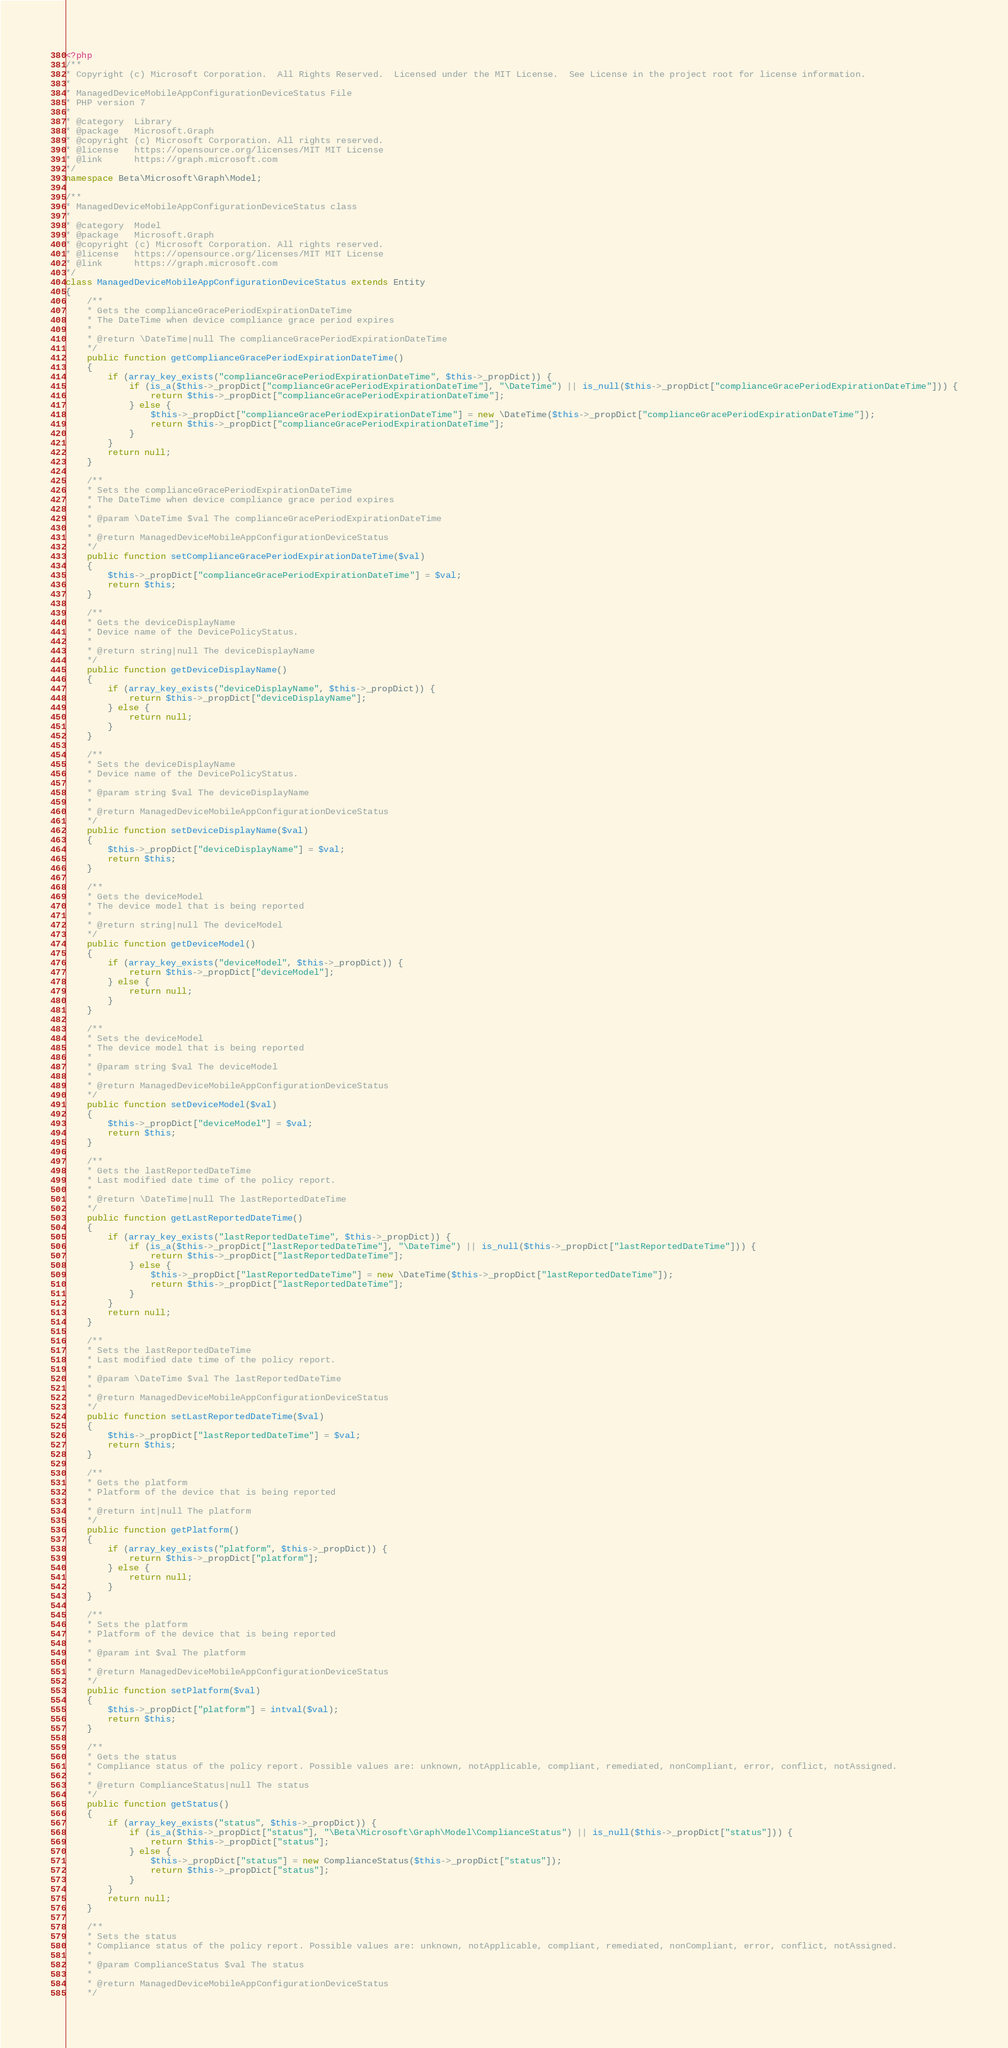<code> <loc_0><loc_0><loc_500><loc_500><_PHP_><?php
/**
* Copyright (c) Microsoft Corporation.  All Rights Reserved.  Licensed under the MIT License.  See License in the project root for license information.
* 
* ManagedDeviceMobileAppConfigurationDeviceStatus File
* PHP version 7
*
* @category  Library
* @package   Microsoft.Graph
* @copyright (c) Microsoft Corporation. All rights reserved.
* @license   https://opensource.org/licenses/MIT MIT License
* @link      https://graph.microsoft.com
*/
namespace Beta\Microsoft\Graph\Model;

/**
* ManagedDeviceMobileAppConfigurationDeviceStatus class
*
* @category  Model
* @package   Microsoft.Graph
* @copyright (c) Microsoft Corporation. All rights reserved.
* @license   https://opensource.org/licenses/MIT MIT License
* @link      https://graph.microsoft.com
*/
class ManagedDeviceMobileAppConfigurationDeviceStatus extends Entity
{
    /**
    * Gets the complianceGracePeriodExpirationDateTime
    * The DateTime when device compliance grace period expires
    *
    * @return \DateTime|null The complianceGracePeriodExpirationDateTime
    */
    public function getComplianceGracePeriodExpirationDateTime()
    {
        if (array_key_exists("complianceGracePeriodExpirationDateTime", $this->_propDict)) {
            if (is_a($this->_propDict["complianceGracePeriodExpirationDateTime"], "\DateTime") || is_null($this->_propDict["complianceGracePeriodExpirationDateTime"])) {
                return $this->_propDict["complianceGracePeriodExpirationDateTime"];
            } else {
                $this->_propDict["complianceGracePeriodExpirationDateTime"] = new \DateTime($this->_propDict["complianceGracePeriodExpirationDateTime"]);
                return $this->_propDict["complianceGracePeriodExpirationDateTime"];
            }
        }
        return null;
    }

    /**
    * Sets the complianceGracePeriodExpirationDateTime
    * The DateTime when device compliance grace period expires
    *
    * @param \DateTime $val The complianceGracePeriodExpirationDateTime
    *
    * @return ManagedDeviceMobileAppConfigurationDeviceStatus
    */
    public function setComplianceGracePeriodExpirationDateTime($val)
    {
        $this->_propDict["complianceGracePeriodExpirationDateTime"] = $val;
        return $this;
    }

    /**
    * Gets the deviceDisplayName
    * Device name of the DevicePolicyStatus.
    *
    * @return string|null The deviceDisplayName
    */
    public function getDeviceDisplayName()
    {
        if (array_key_exists("deviceDisplayName", $this->_propDict)) {
            return $this->_propDict["deviceDisplayName"];
        } else {
            return null;
        }
    }

    /**
    * Sets the deviceDisplayName
    * Device name of the DevicePolicyStatus.
    *
    * @param string $val The deviceDisplayName
    *
    * @return ManagedDeviceMobileAppConfigurationDeviceStatus
    */
    public function setDeviceDisplayName($val)
    {
        $this->_propDict["deviceDisplayName"] = $val;
        return $this;
    }

    /**
    * Gets the deviceModel
    * The device model that is being reported
    *
    * @return string|null The deviceModel
    */
    public function getDeviceModel()
    {
        if (array_key_exists("deviceModel", $this->_propDict)) {
            return $this->_propDict["deviceModel"];
        } else {
            return null;
        }
    }

    /**
    * Sets the deviceModel
    * The device model that is being reported
    *
    * @param string $val The deviceModel
    *
    * @return ManagedDeviceMobileAppConfigurationDeviceStatus
    */
    public function setDeviceModel($val)
    {
        $this->_propDict["deviceModel"] = $val;
        return $this;
    }

    /**
    * Gets the lastReportedDateTime
    * Last modified date time of the policy report.
    *
    * @return \DateTime|null The lastReportedDateTime
    */
    public function getLastReportedDateTime()
    {
        if (array_key_exists("lastReportedDateTime", $this->_propDict)) {
            if (is_a($this->_propDict["lastReportedDateTime"], "\DateTime") || is_null($this->_propDict["lastReportedDateTime"])) {
                return $this->_propDict["lastReportedDateTime"];
            } else {
                $this->_propDict["lastReportedDateTime"] = new \DateTime($this->_propDict["lastReportedDateTime"]);
                return $this->_propDict["lastReportedDateTime"];
            }
        }
        return null;
    }

    /**
    * Sets the lastReportedDateTime
    * Last modified date time of the policy report.
    *
    * @param \DateTime $val The lastReportedDateTime
    *
    * @return ManagedDeviceMobileAppConfigurationDeviceStatus
    */
    public function setLastReportedDateTime($val)
    {
        $this->_propDict["lastReportedDateTime"] = $val;
        return $this;
    }

    /**
    * Gets the platform
    * Platform of the device that is being reported
    *
    * @return int|null The platform
    */
    public function getPlatform()
    {
        if (array_key_exists("platform", $this->_propDict)) {
            return $this->_propDict["platform"];
        } else {
            return null;
        }
    }

    /**
    * Sets the platform
    * Platform of the device that is being reported
    *
    * @param int $val The platform
    *
    * @return ManagedDeviceMobileAppConfigurationDeviceStatus
    */
    public function setPlatform($val)
    {
        $this->_propDict["platform"] = intval($val);
        return $this;
    }

    /**
    * Gets the status
    * Compliance status of the policy report. Possible values are: unknown, notApplicable, compliant, remediated, nonCompliant, error, conflict, notAssigned.
    *
    * @return ComplianceStatus|null The status
    */
    public function getStatus()
    {
        if (array_key_exists("status", $this->_propDict)) {
            if (is_a($this->_propDict["status"], "\Beta\Microsoft\Graph\Model\ComplianceStatus") || is_null($this->_propDict["status"])) {
                return $this->_propDict["status"];
            } else {
                $this->_propDict["status"] = new ComplianceStatus($this->_propDict["status"]);
                return $this->_propDict["status"];
            }
        }
        return null;
    }

    /**
    * Sets the status
    * Compliance status of the policy report. Possible values are: unknown, notApplicable, compliant, remediated, nonCompliant, error, conflict, notAssigned.
    *
    * @param ComplianceStatus $val The status
    *
    * @return ManagedDeviceMobileAppConfigurationDeviceStatus
    */</code> 